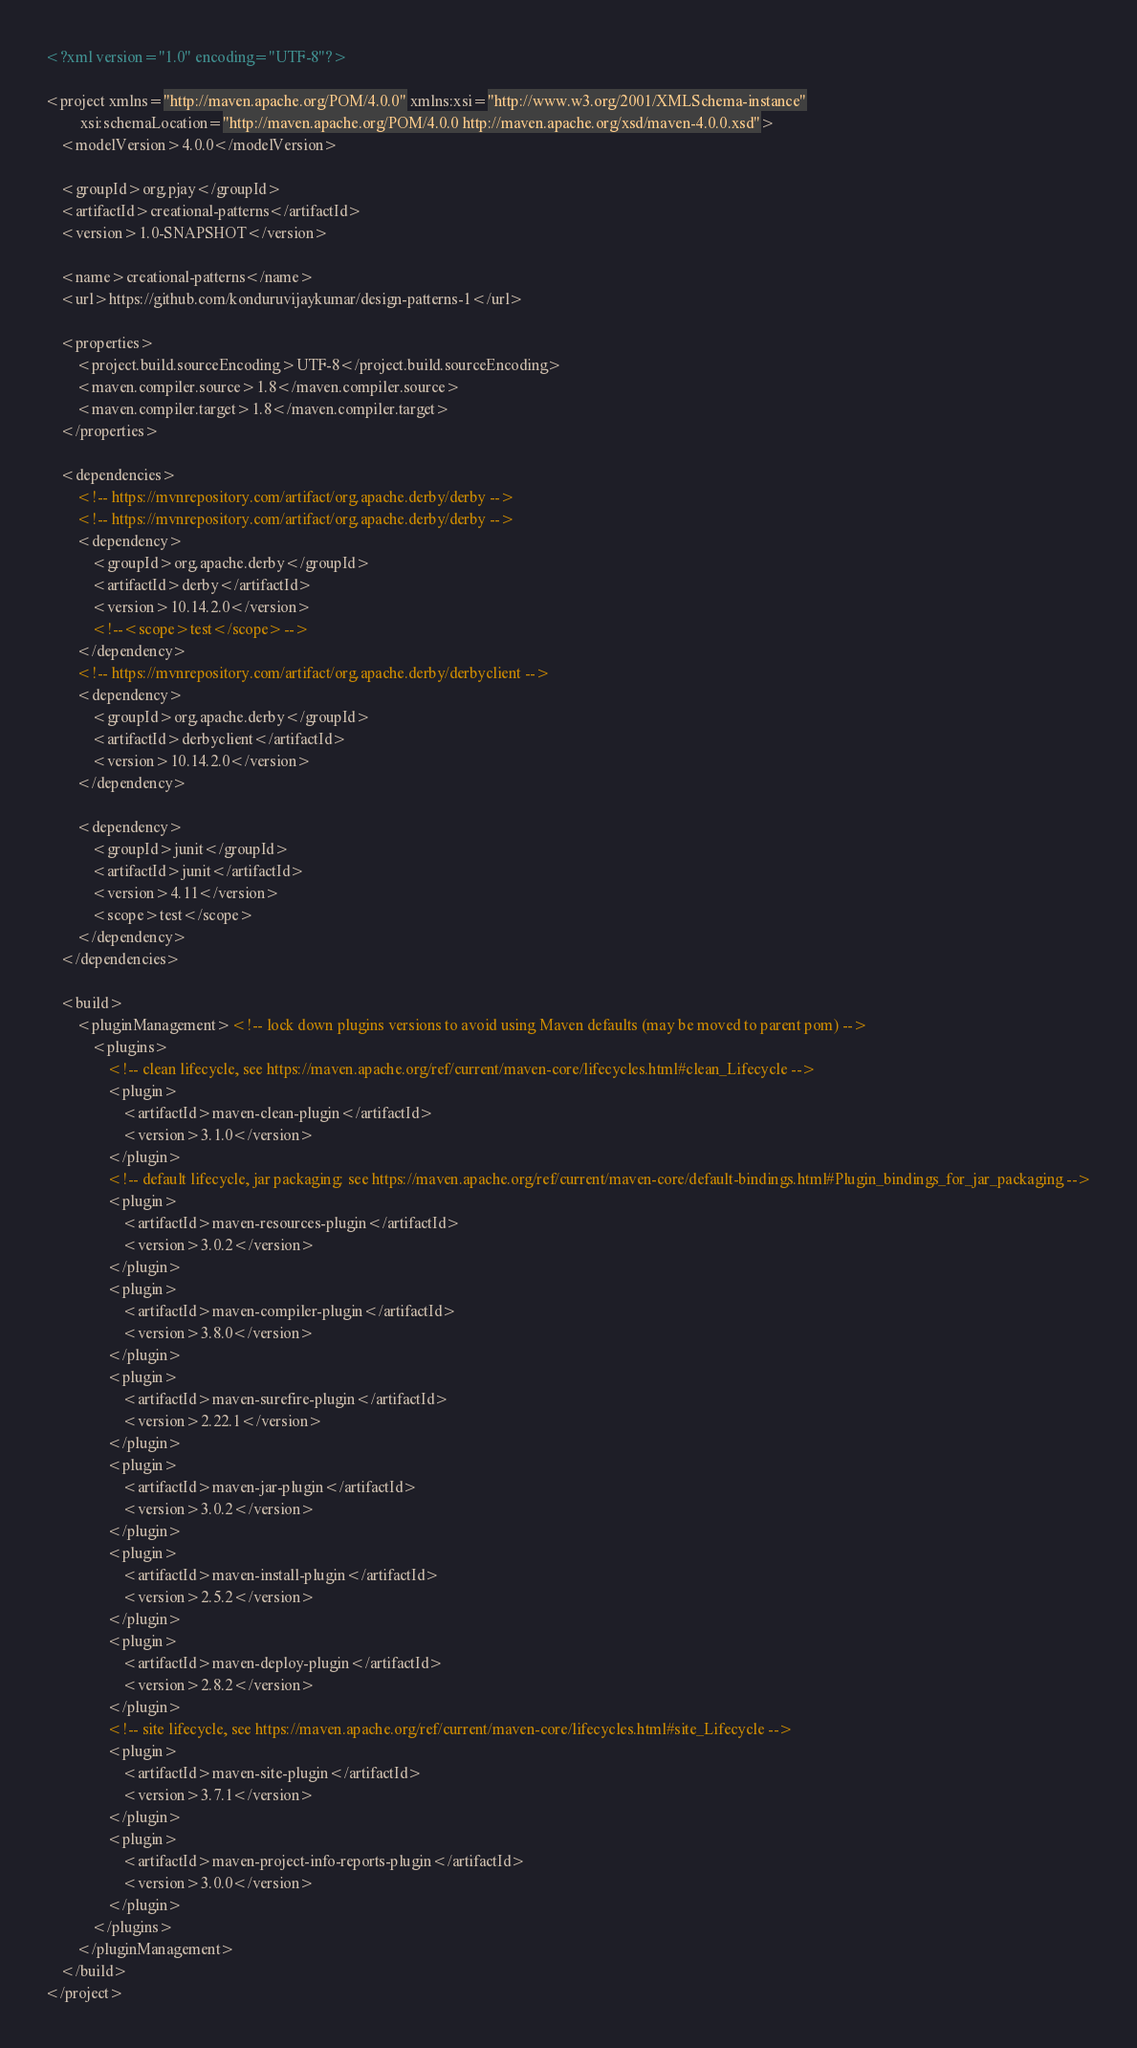Convert code to text. <code><loc_0><loc_0><loc_500><loc_500><_XML_><?xml version="1.0" encoding="UTF-8"?>

<project xmlns="http://maven.apache.org/POM/4.0.0" xmlns:xsi="http://www.w3.org/2001/XMLSchema-instance"
         xsi:schemaLocation="http://maven.apache.org/POM/4.0.0 http://maven.apache.org/xsd/maven-4.0.0.xsd">
    <modelVersion>4.0.0</modelVersion>

    <groupId>org.pjay</groupId>
    <artifactId>creational-patterns</artifactId>
    <version>1.0-SNAPSHOT</version>

    <name>creational-patterns</name>
    <url>https://github.com/konduruvijaykumar/design-patterns-1</url>

    <properties>
        <project.build.sourceEncoding>UTF-8</project.build.sourceEncoding>
        <maven.compiler.source>1.8</maven.compiler.source>
        <maven.compiler.target>1.8</maven.compiler.target>
    </properties>

    <dependencies>
        <!-- https://mvnrepository.com/artifact/org.apache.derby/derby -->
        <!-- https://mvnrepository.com/artifact/org.apache.derby/derby -->
        <dependency>
            <groupId>org.apache.derby</groupId>
            <artifactId>derby</artifactId>
            <version>10.14.2.0</version>
            <!--<scope>test</scope>-->
        </dependency>
        <!-- https://mvnrepository.com/artifact/org.apache.derby/derbyclient -->
        <dependency>
            <groupId>org.apache.derby</groupId>
            <artifactId>derbyclient</artifactId>
            <version>10.14.2.0</version>
        </dependency>

        <dependency>
            <groupId>junit</groupId>
            <artifactId>junit</artifactId>
            <version>4.11</version>
            <scope>test</scope>
        </dependency>
    </dependencies>

    <build>
        <pluginManagement><!-- lock down plugins versions to avoid using Maven defaults (may be moved to parent pom) -->
            <plugins>
                <!-- clean lifecycle, see https://maven.apache.org/ref/current/maven-core/lifecycles.html#clean_Lifecycle -->
                <plugin>
                    <artifactId>maven-clean-plugin</artifactId>
                    <version>3.1.0</version>
                </plugin>
                <!-- default lifecycle, jar packaging: see https://maven.apache.org/ref/current/maven-core/default-bindings.html#Plugin_bindings_for_jar_packaging -->
                <plugin>
                    <artifactId>maven-resources-plugin</artifactId>
                    <version>3.0.2</version>
                </plugin>
                <plugin>
                    <artifactId>maven-compiler-plugin</artifactId>
                    <version>3.8.0</version>
                </plugin>
                <plugin>
                    <artifactId>maven-surefire-plugin</artifactId>
                    <version>2.22.1</version>
                </plugin>
                <plugin>
                    <artifactId>maven-jar-plugin</artifactId>
                    <version>3.0.2</version>
                </plugin>
                <plugin>
                    <artifactId>maven-install-plugin</artifactId>
                    <version>2.5.2</version>
                </plugin>
                <plugin>
                    <artifactId>maven-deploy-plugin</artifactId>
                    <version>2.8.2</version>
                </plugin>
                <!-- site lifecycle, see https://maven.apache.org/ref/current/maven-core/lifecycles.html#site_Lifecycle -->
                <plugin>
                    <artifactId>maven-site-plugin</artifactId>
                    <version>3.7.1</version>
                </plugin>
                <plugin>
                    <artifactId>maven-project-info-reports-plugin</artifactId>
                    <version>3.0.0</version>
                </plugin>
            </plugins>
        </pluginManagement>
    </build>
</project>
</code> 